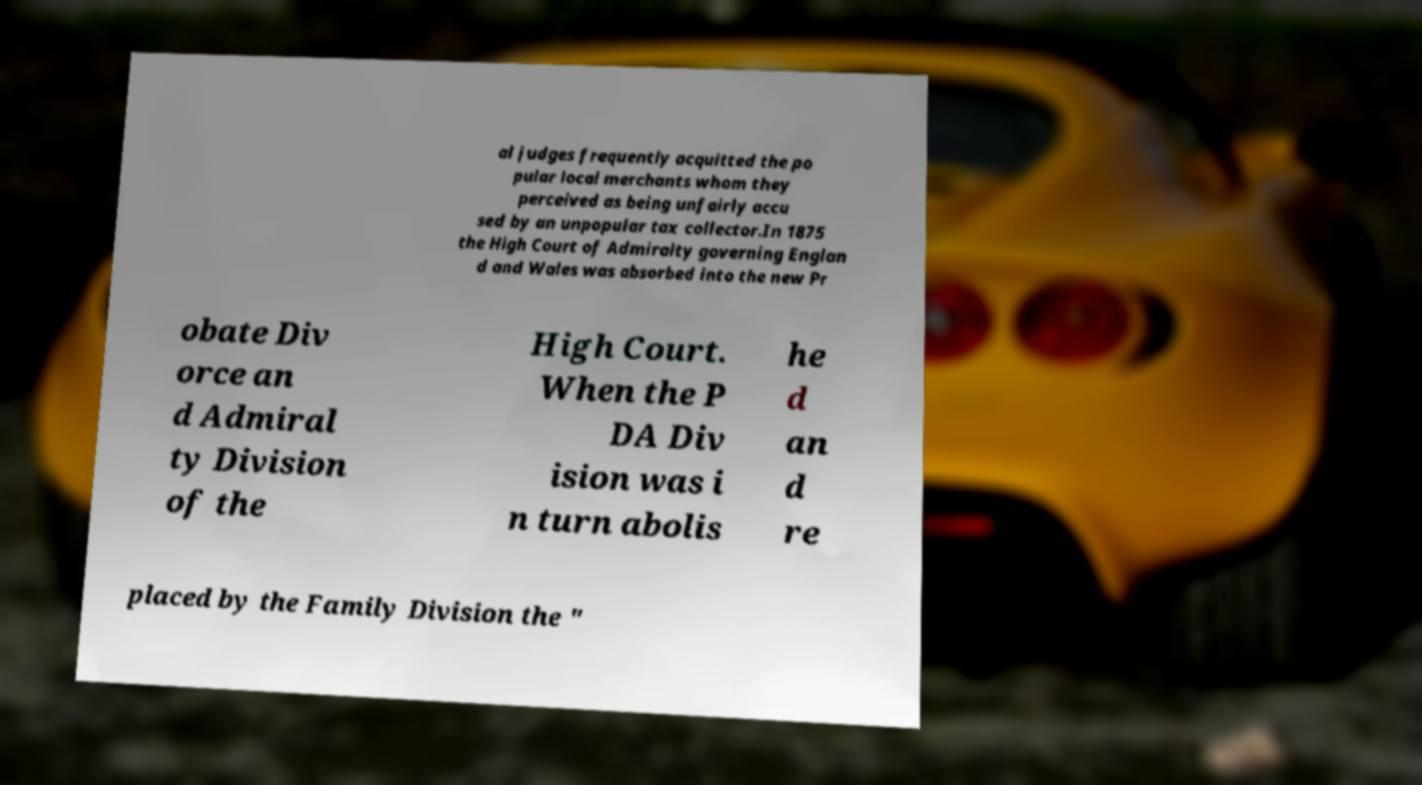Can you read and provide the text displayed in the image?This photo seems to have some interesting text. Can you extract and type it out for me? al judges frequently acquitted the po pular local merchants whom they perceived as being unfairly accu sed by an unpopular tax collector.In 1875 the High Court of Admiralty governing Englan d and Wales was absorbed into the new Pr obate Div orce an d Admiral ty Division of the High Court. When the P DA Div ision was i n turn abolis he d an d re placed by the Family Division the " 